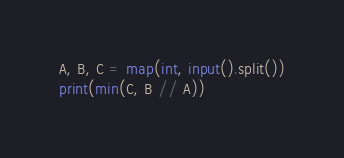Convert code to text. <code><loc_0><loc_0><loc_500><loc_500><_Python_>A, B, C = map(int, input().split())
print(min(C, B // A))</code> 